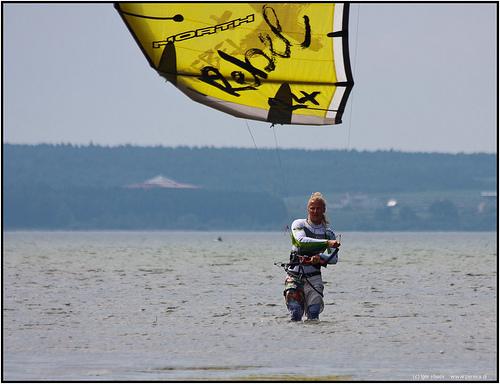What is this person doing?
Give a very brief answer. Parasailing. What is the purpose of the sail?
Keep it brief. To pull woman. What word on the sail is also the name of a Kardashian child?
Write a very short answer. North. What is the yellow object?
Short answer required. Sail. 